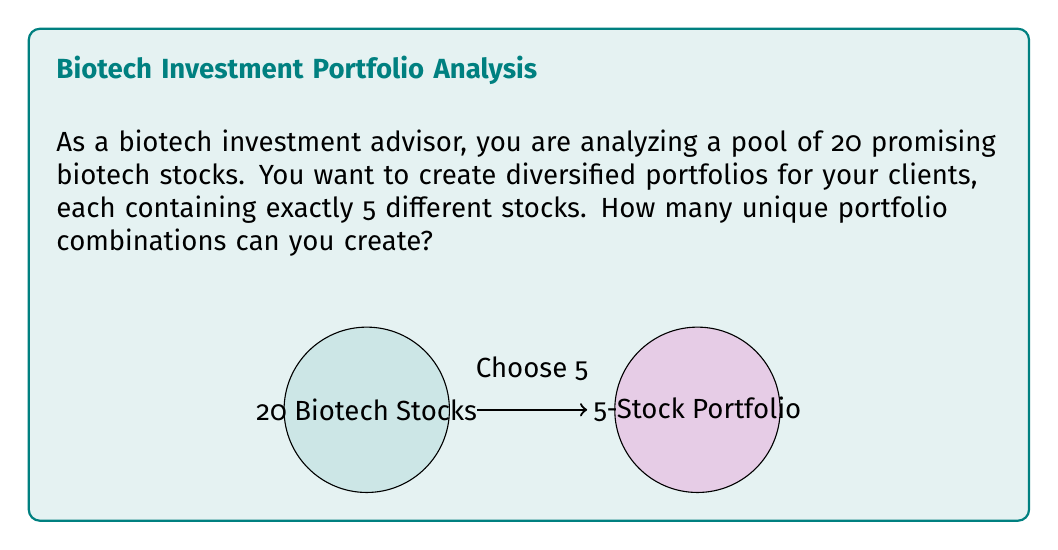Teach me how to tackle this problem. To solve this problem, we need to use the combination formula. We are selecting 5 stocks from a pool of 20, where the order doesn't matter (as we're just creating sets of stocks, not ordered lists).

The formula for combinations is:

$$C(n,r) = \frac{n!}{r!(n-r)!}$$

Where:
$n$ is the total number of items to choose from (in this case, 20 stocks)
$r$ is the number of items being chosen (in this case, 5 stocks)

Let's substitute our values:

$$C(20,5) = \frac{20!}{5!(20-5)!} = \frac{20!}{5!15!}$$

Now, let's calculate this step-by-step:

1) $20! = 2432902008176640000$
2) $5! = 120$
3) $15! = 1307674368000$

$$\frac{20!}{5!15!} = \frac{2432902008176640000}{120 \times 1307674368000}$$

$$= \frac{2432902008176640000}{156920924160000}$$

$$= 15504$$

Therefore, you can create 15,504 unique portfolio combinations.
Answer: 15,504 